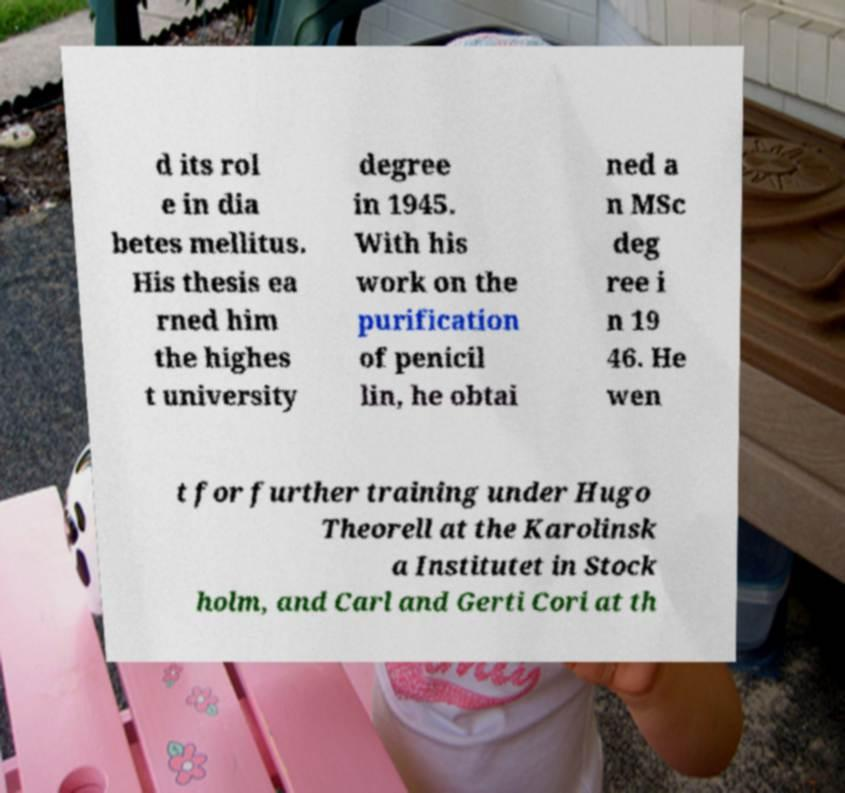Please read and relay the text visible in this image. What does it say? d its rol e in dia betes mellitus. His thesis ea rned him the highes t university degree in 1945. With his work on the purification of penicil lin, he obtai ned a n MSc deg ree i n 19 46. He wen t for further training under Hugo Theorell at the Karolinsk a Institutet in Stock holm, and Carl and Gerti Cori at th 